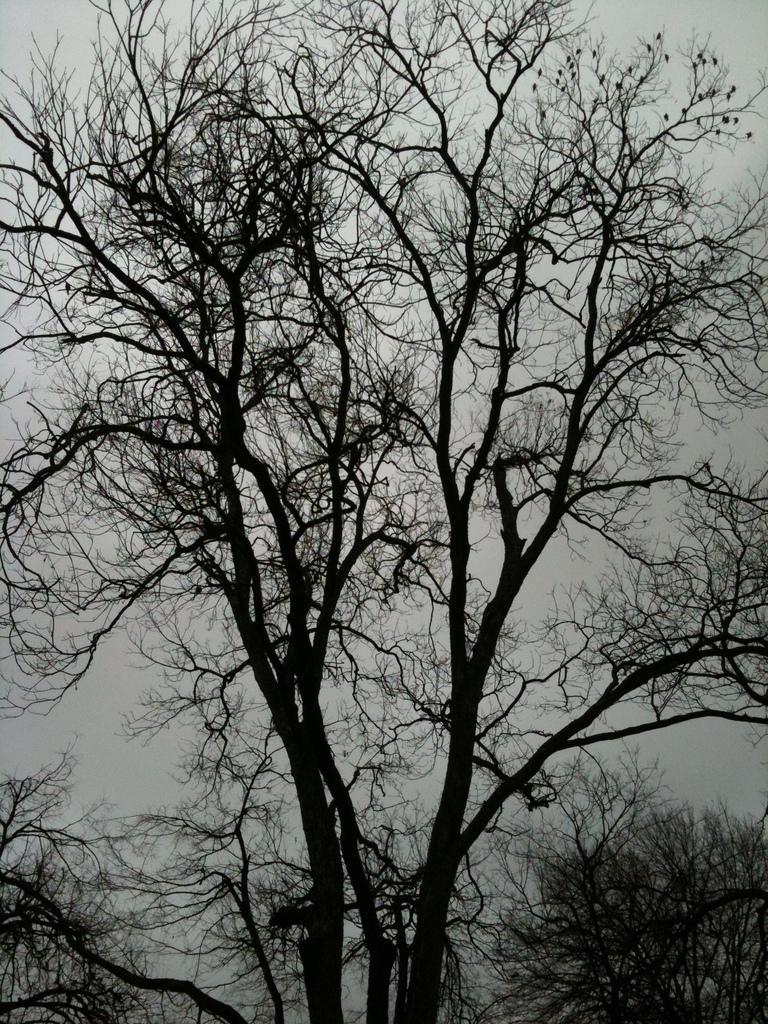Could you give a brief overview of what you see in this image? In this image I can see trees. In the background I can see the sky. 